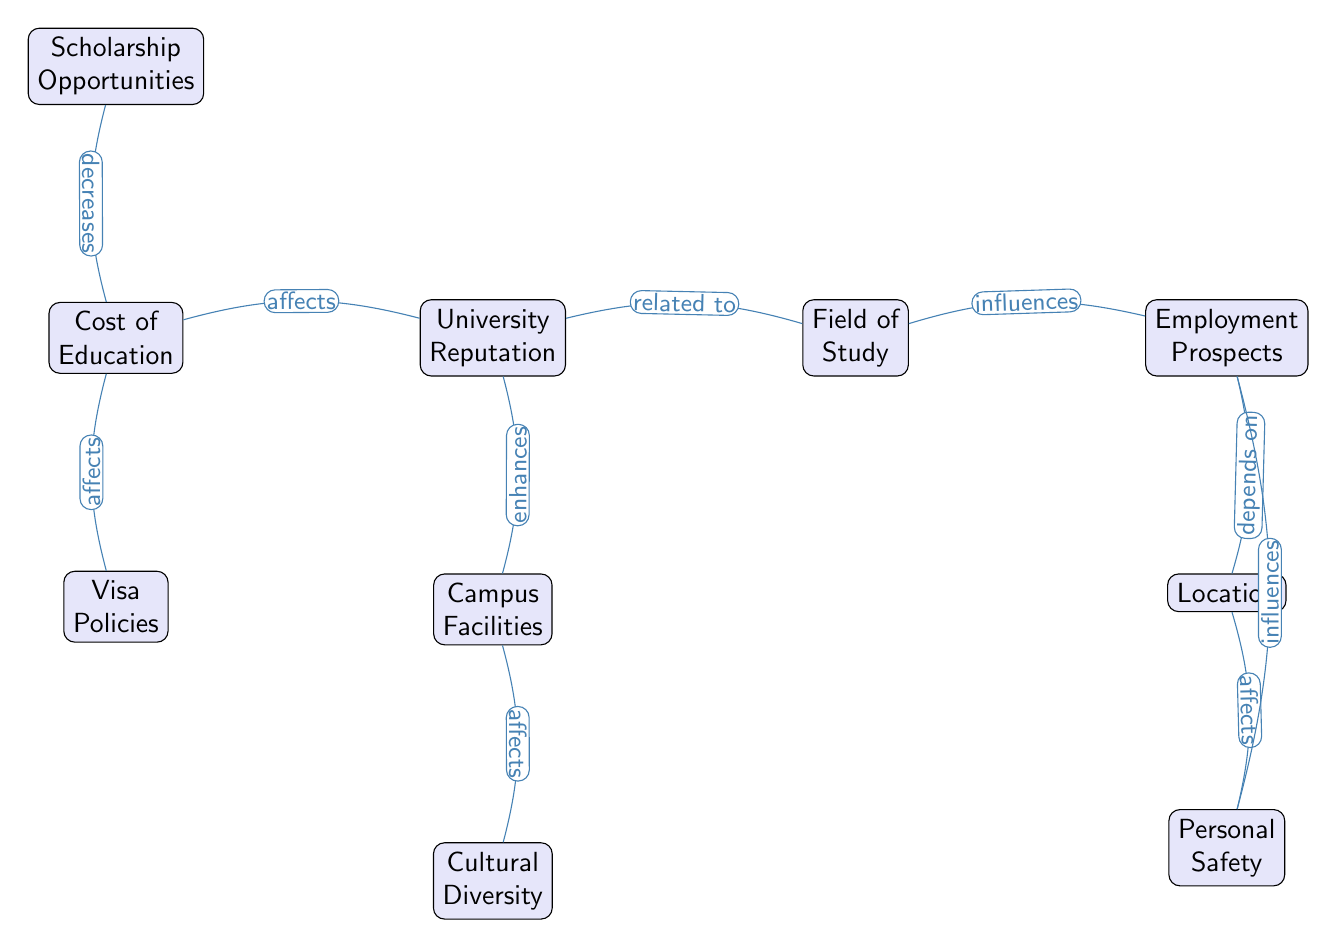What is the first factor listed in the diagram? The diagram starts with the node labeled "Cost of Education," which is positioned at the top left.
Answer: Cost of Education How many nodes are present in the diagram? By counting all the individual factors represented in the diagram, there are ten distinct nodes listed, each corresponding to a different factor.
Answer: 10 Which factor influences Employment Prospects? The diagram indicates that "Field of Study" influences "Employment Prospects," as there is a directed edge from one to the other showing a causal relationship.
Answer: Field of Study What is the relationship between University Reputation and Campus Facilities? The diagram shows that "University Reputation" has an enhancing effect on "Campus Facilities," indicated by the labeled edge connecting these two nodes.
Answer: enhances Which two factors have a direct connection to Cost of Education? The edges indicate that "Scholarship Opportunities" and "Visa Policies" both affect "Cost of Education," creating a direct relationship with this node.
Answer: Scholarship Opportunities, Visa Policies How does Culture Diversity affect Campus Facilities? "Cultural Diversity" positively influences "Campus Facilities," as indicated by the directed edge from "Cultural Diversity" to "Campus Facilities," showing a causal effect in the diagram.
Answer: affects Explain how Location relates to Personal Safety. The diagram shows that "Location" affects "Personal Safety," indicating a direct relationship with a directed edge that signifies that location influences the perceived safety of international students.
Answer: affects Which node has the most connections or influences in the diagram? By analyzing the edges leading to and from individual nodes, "Employment Prospects" and "Cost of Education" show multiple connections, specifically, each being influenced or affecting several other factors.
Answer: Employment Prospects, Cost of Education What effect do Scholarship Opportunities have on Cost of Education? The diagram shows that "Scholarship Opportunities" decreases the "Cost of Education," as indicated by the directed edge that shows a downward association with this factor.
Answer: decreases 